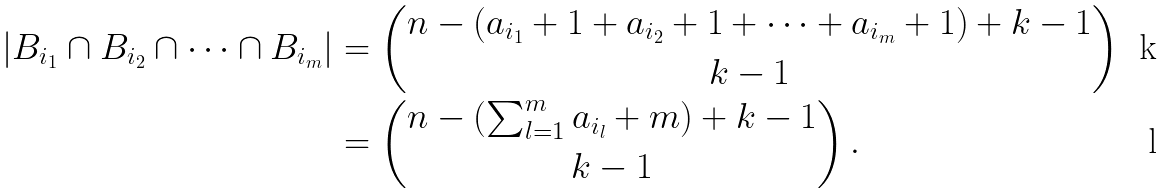<formula> <loc_0><loc_0><loc_500><loc_500>| B _ { i _ { 1 } } \cap B _ { i _ { 2 } } \cap \dots \cap B _ { i _ { m } } | & = \binom { n - ( a _ { i _ { 1 } } + 1 + a _ { i _ { 2 } } + 1 + \dots + a _ { i _ { m } } + 1 ) + k - 1 } { k - 1 } \\ & = \binom { n - ( \sum _ { l = 1 } ^ { m } a _ { i _ { l } } + m ) + k - 1 } { k - 1 } \, .</formula> 